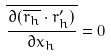<formula> <loc_0><loc_0><loc_500><loc_500>\overline { \frac { \partial ( \overline { r _ { h } } \cdot r _ { h } ^ { \prime } ) } { \partial x _ { h } } } = 0</formula> 